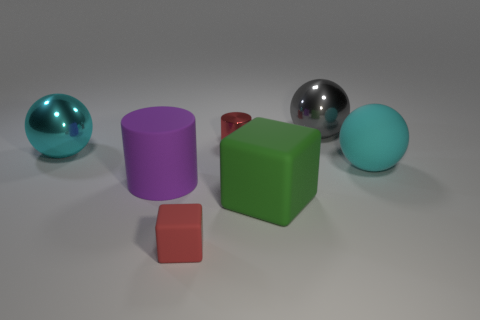Add 1 big cyan shiny objects. How many objects exist? 8 Subtract all red cylinders. How many cylinders are left? 1 Subtract all cyan metal balls. How many balls are left? 2 Subtract all balls. How many objects are left? 4 Subtract 2 spheres. How many spheres are left? 1 Subtract 0 blue balls. How many objects are left? 7 Subtract all red cubes. Subtract all brown balls. How many cubes are left? 1 Subtract all yellow spheres. How many red cylinders are left? 1 Subtract all tiny yellow matte cylinders. Subtract all tiny red cylinders. How many objects are left? 6 Add 1 red things. How many red things are left? 3 